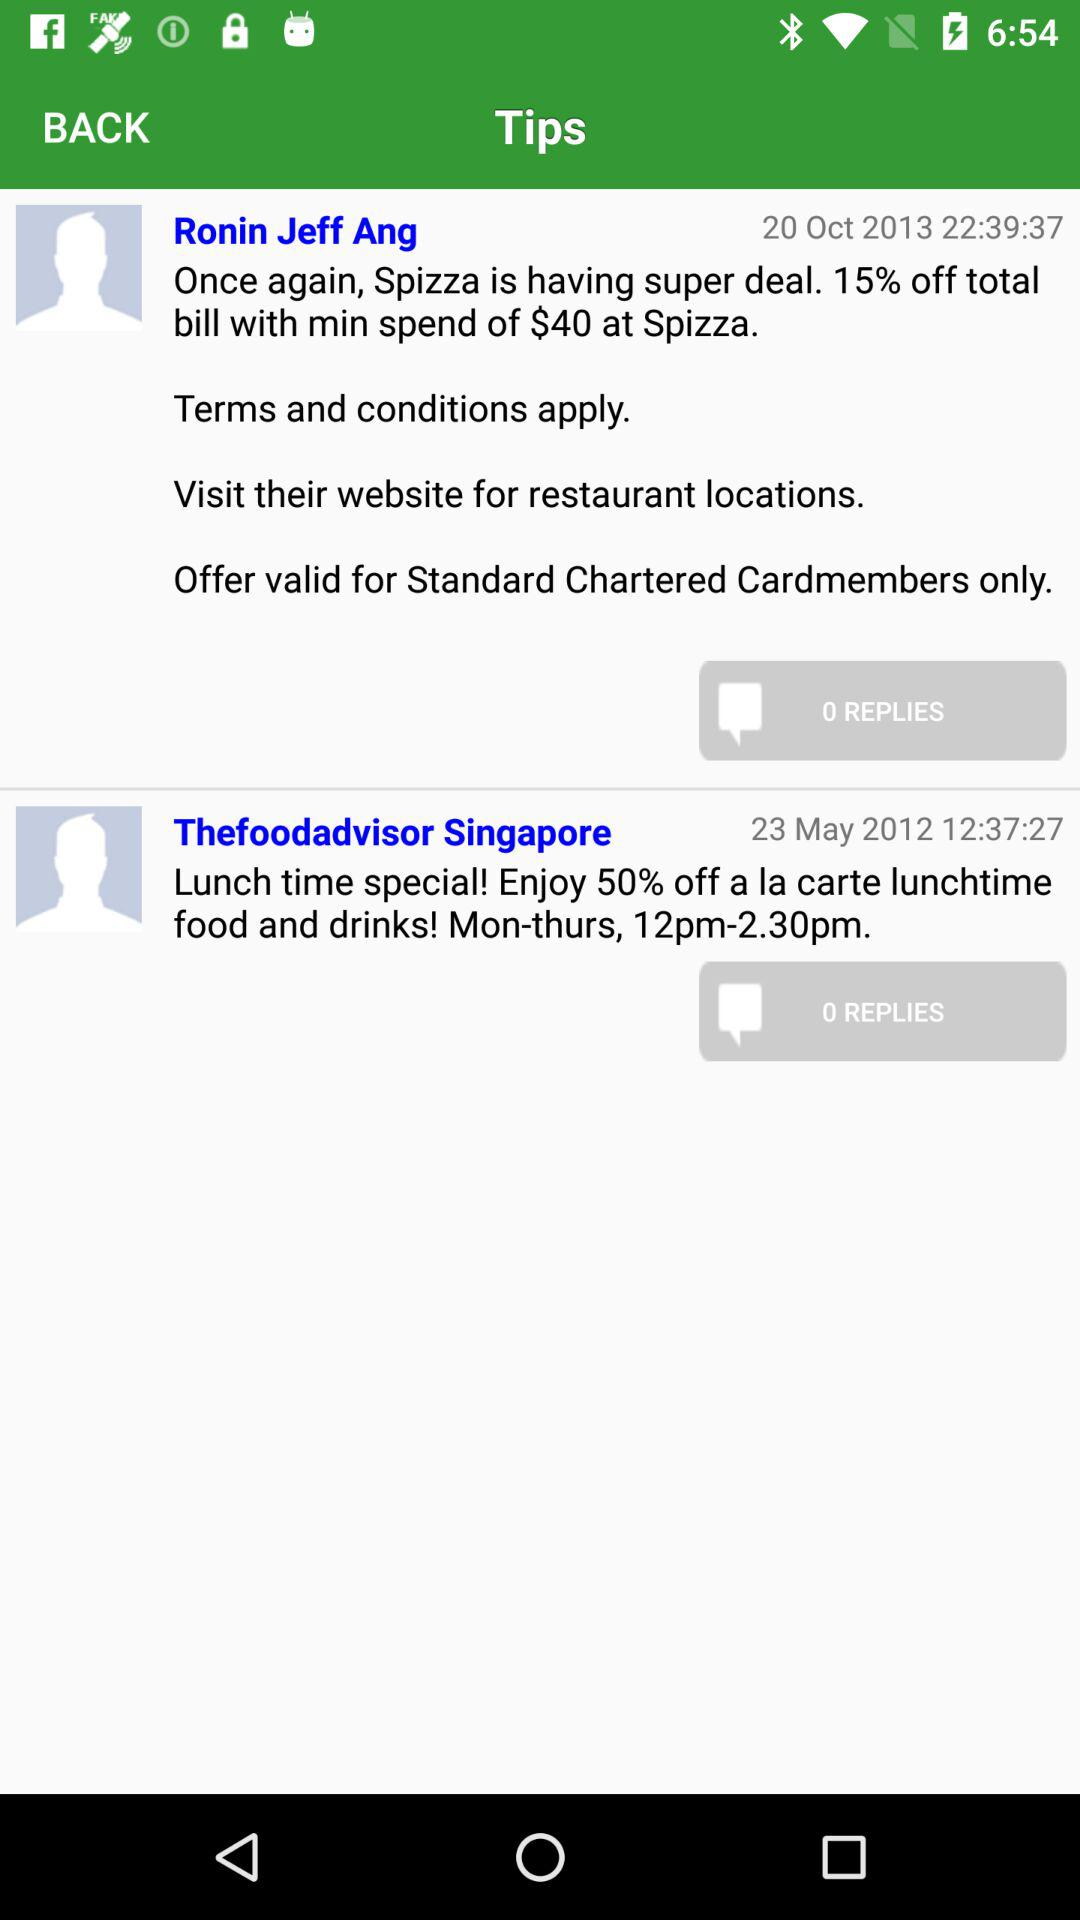What time is shown on October 20, 2013? The shown time is 22:39:37. 